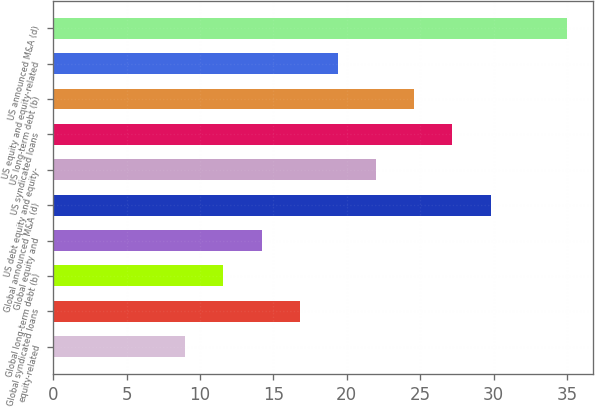<chart> <loc_0><loc_0><loc_500><loc_500><bar_chart><fcel>equity-related<fcel>Global syndicated loans<fcel>Global long-term debt (b)<fcel>Global equity and<fcel>Global announced M&A (d)<fcel>US debt equity and equity-<fcel>US syndicated loans<fcel>US long-term debt (b)<fcel>US equity and equity-related<fcel>US announced M&A (d)<nl><fcel>9<fcel>16.8<fcel>11.6<fcel>14.2<fcel>29.8<fcel>22<fcel>27.2<fcel>24.6<fcel>19.4<fcel>35<nl></chart> 